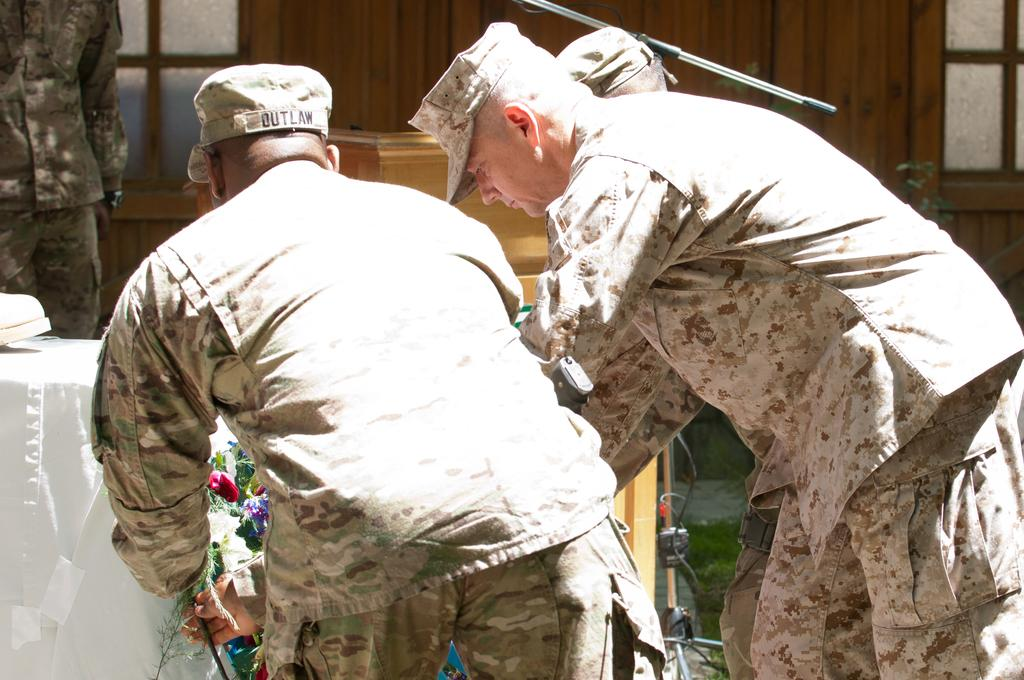What are the people in the image doing? The people in the image are standing and holding flowers. What can be seen on the table in the image? There is a cloth on the table in the image. What is visible in the background of the image? There is a window, a stand, and a wooden object in the background of the image. What color are the eyes of the wooden object in the image? There are no eyes present on the wooden object in the image, as it is an inanimate object. 